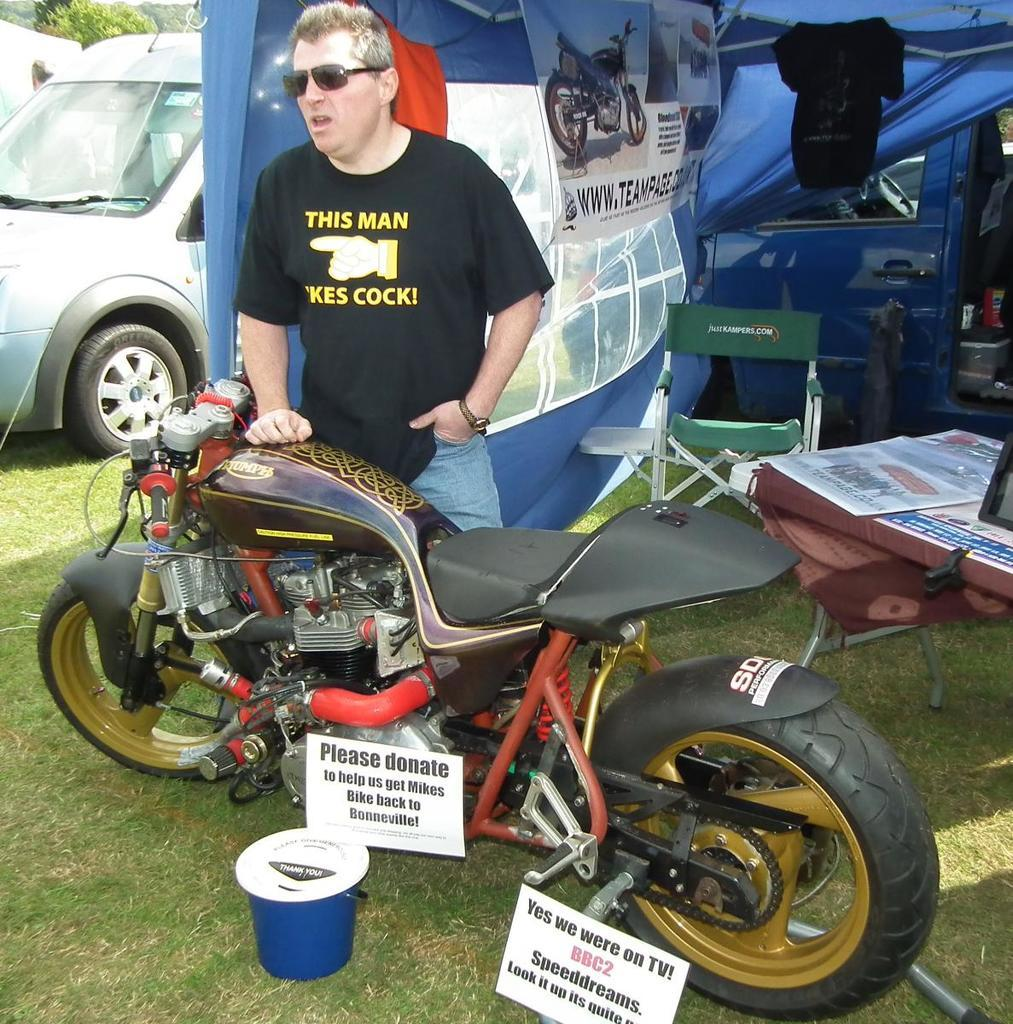What type of objects are on the ground in the image? There are motor vehicles on the ground in the image. Can you describe the person in the image? There is a person standing on the ground in the image. What type of shelter is visible in the image? There is a tent in the image. What type of furniture is visible in the image? There is a chair in the image. What type of container is visible in the image? There is a bin in the image. What type of bird is perched on the chair in the image? There is no bird present in the image; it only features motor vehicles, a person, a tent, a chair, and a bin. What type of quill is used by the person in the image? There is no quill present in the image, nor is there any indication that the person is using one. 